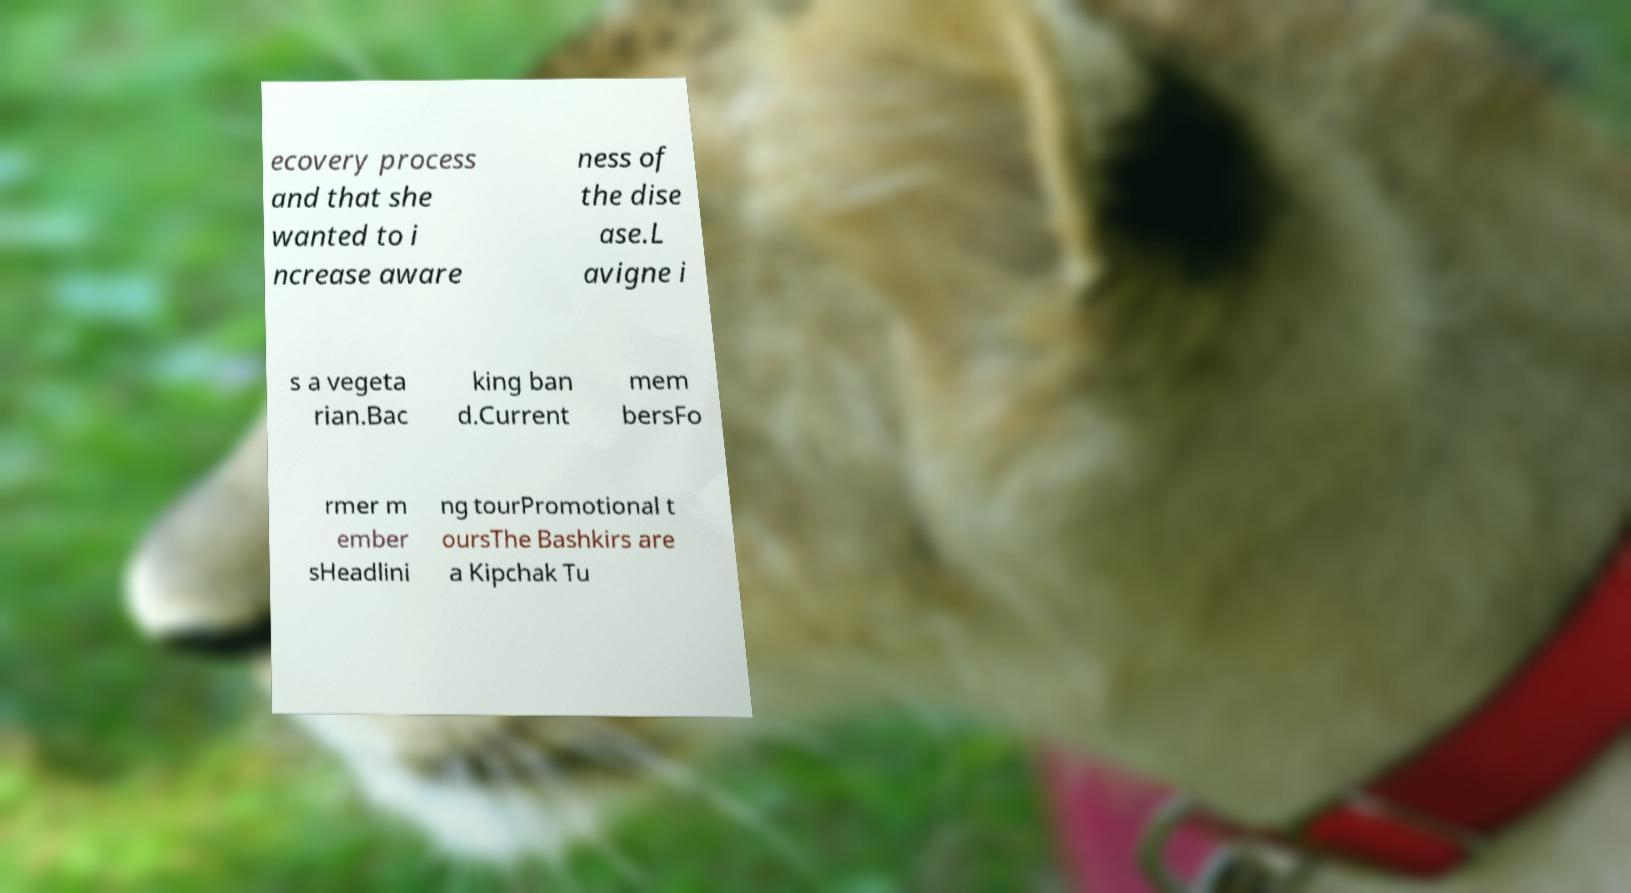What messages or text are displayed in this image? I need them in a readable, typed format. ecovery process and that she wanted to i ncrease aware ness of the dise ase.L avigne i s a vegeta rian.Bac king ban d.Current mem bersFo rmer m ember sHeadlini ng tourPromotional t oursThe Bashkirs are a Kipchak Tu 